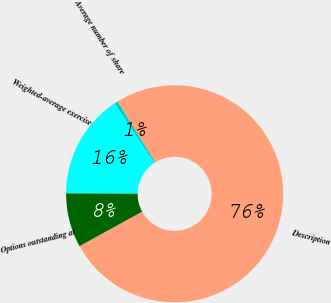Convert chart to OTSL. <chart><loc_0><loc_0><loc_500><loc_500><pie_chart><fcel>Description<fcel>Average number of share<fcel>Weighted-average exercise<fcel>Options outstanding at<nl><fcel>75.83%<fcel>0.52%<fcel>15.59%<fcel>8.06%<nl></chart> 